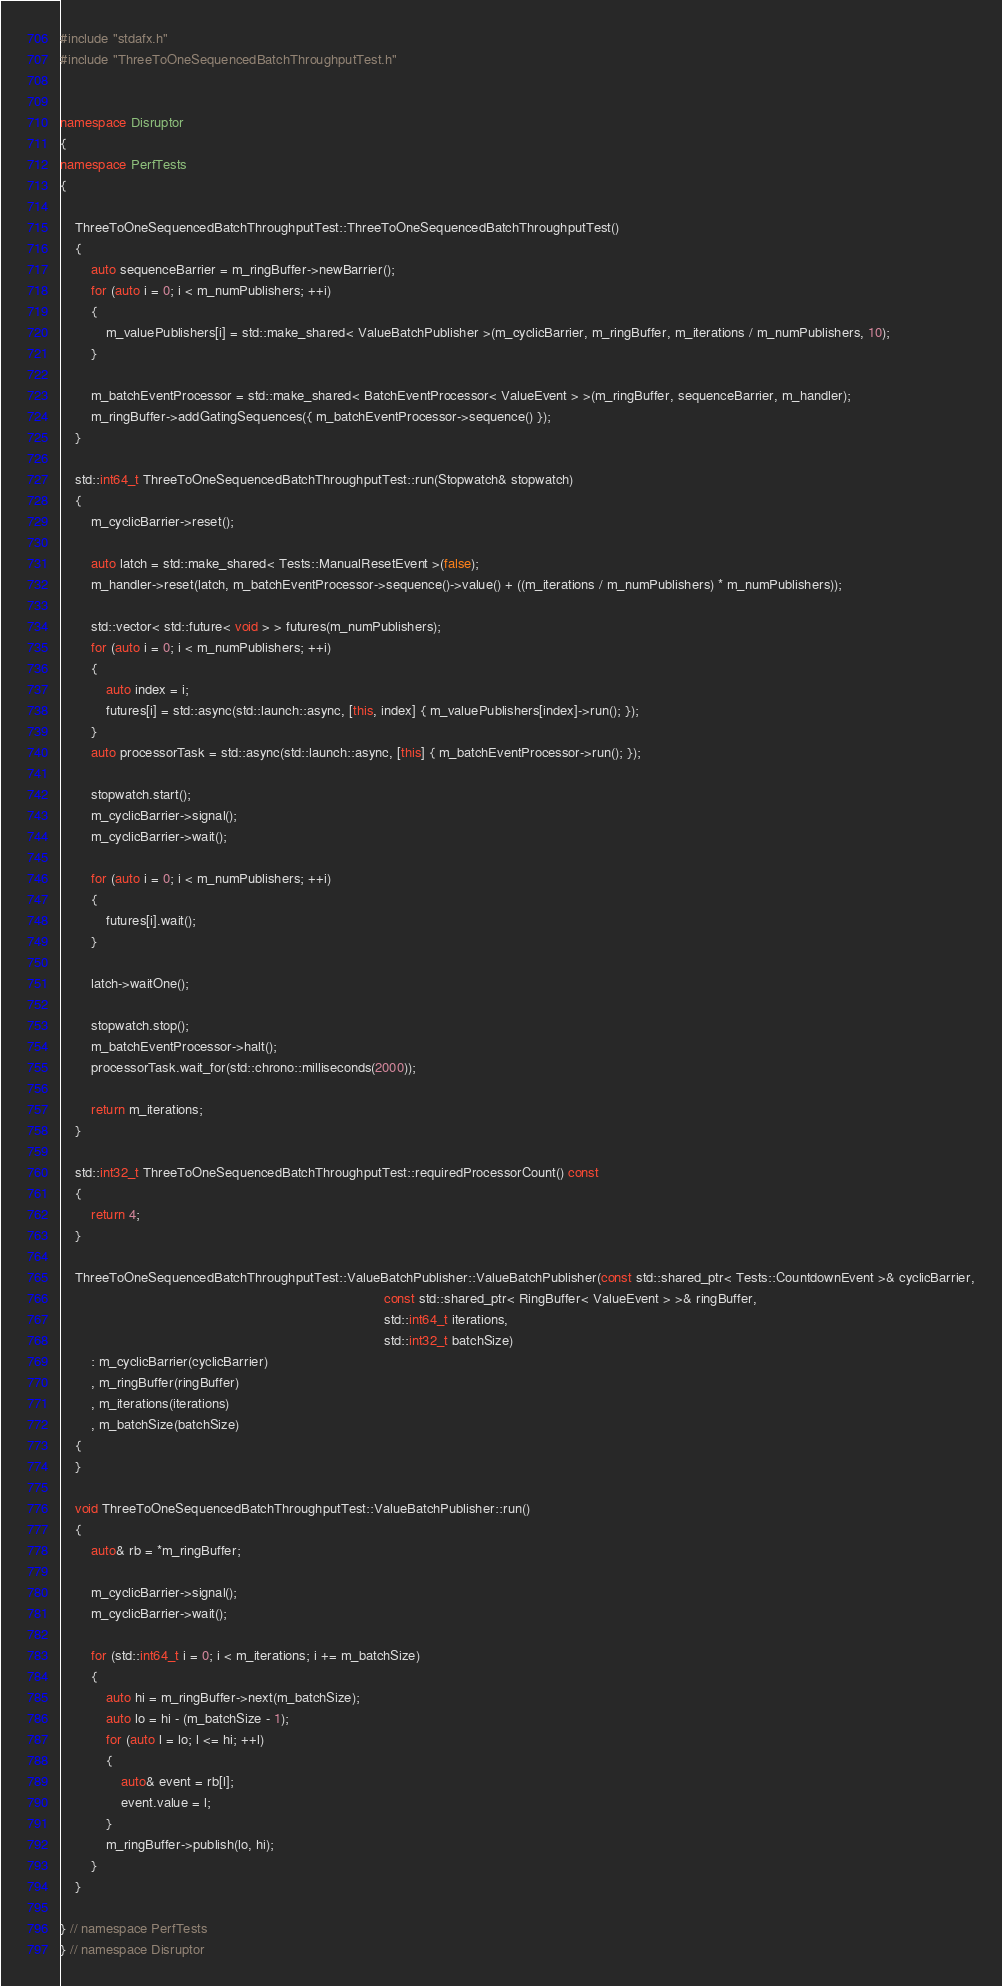Convert code to text. <code><loc_0><loc_0><loc_500><loc_500><_C++_>#include "stdafx.h"
#include "ThreeToOneSequencedBatchThroughputTest.h"


namespace Disruptor
{
namespace PerfTests
{

    ThreeToOneSequencedBatchThroughputTest::ThreeToOneSequencedBatchThroughputTest()
    {
        auto sequenceBarrier = m_ringBuffer->newBarrier();
        for (auto i = 0; i < m_numPublishers; ++i)
        {
            m_valuePublishers[i] = std::make_shared< ValueBatchPublisher >(m_cyclicBarrier, m_ringBuffer, m_iterations / m_numPublishers, 10);
        }

        m_batchEventProcessor = std::make_shared< BatchEventProcessor< ValueEvent > >(m_ringBuffer, sequenceBarrier, m_handler);
        m_ringBuffer->addGatingSequences({ m_batchEventProcessor->sequence() });
    }

    std::int64_t ThreeToOneSequencedBatchThroughputTest::run(Stopwatch& stopwatch)
    {
        m_cyclicBarrier->reset();

        auto latch = std::make_shared< Tests::ManualResetEvent >(false);
        m_handler->reset(latch, m_batchEventProcessor->sequence()->value() + ((m_iterations / m_numPublishers) * m_numPublishers));

        std::vector< std::future< void > > futures(m_numPublishers);
        for (auto i = 0; i < m_numPublishers; ++i)
        {
            auto index = i;
            futures[i] = std::async(std::launch::async, [this, index] { m_valuePublishers[index]->run(); });
        }
        auto processorTask = std::async(std::launch::async, [this] { m_batchEventProcessor->run(); });

        stopwatch.start();
        m_cyclicBarrier->signal();
        m_cyclicBarrier->wait();

        for (auto i = 0; i < m_numPublishers; ++i)
        {
            futures[i].wait();
        }

        latch->waitOne();

        stopwatch.stop();
        m_batchEventProcessor->halt();
        processorTask.wait_for(std::chrono::milliseconds(2000));

        return m_iterations;
    }

    std::int32_t ThreeToOneSequencedBatchThroughputTest::requiredProcessorCount() const
    {
        return 4;
    }

    ThreeToOneSequencedBatchThroughputTest::ValueBatchPublisher::ValueBatchPublisher(const std::shared_ptr< Tests::CountdownEvent >& cyclicBarrier,
                                                                                     const std::shared_ptr< RingBuffer< ValueEvent > >& ringBuffer,
                                                                                     std::int64_t iterations,
                                                                                     std::int32_t batchSize)
        : m_cyclicBarrier(cyclicBarrier)
        , m_ringBuffer(ringBuffer)
        , m_iterations(iterations)
        , m_batchSize(batchSize)
    {
    }

    void ThreeToOneSequencedBatchThroughputTest::ValueBatchPublisher::run()
    {
        auto& rb = *m_ringBuffer;

        m_cyclicBarrier->signal();
        m_cyclicBarrier->wait();

        for (std::int64_t i = 0; i < m_iterations; i += m_batchSize)
        {
            auto hi = m_ringBuffer->next(m_batchSize);
            auto lo = hi - (m_batchSize - 1);
            for (auto l = lo; l <= hi; ++l)
            {
                auto& event = rb[l];
                event.value = l;
            }
            m_ringBuffer->publish(lo, hi);
        }
    }

} // namespace PerfTests
} // namespace Disruptor
</code> 